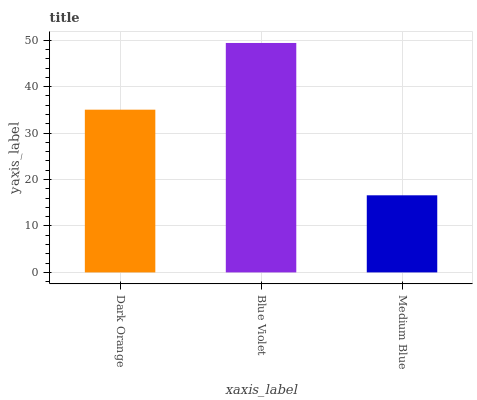Is Blue Violet the minimum?
Answer yes or no. No. Is Medium Blue the maximum?
Answer yes or no. No. Is Blue Violet greater than Medium Blue?
Answer yes or no. Yes. Is Medium Blue less than Blue Violet?
Answer yes or no. Yes. Is Medium Blue greater than Blue Violet?
Answer yes or no. No. Is Blue Violet less than Medium Blue?
Answer yes or no. No. Is Dark Orange the high median?
Answer yes or no. Yes. Is Dark Orange the low median?
Answer yes or no. Yes. Is Blue Violet the high median?
Answer yes or no. No. Is Blue Violet the low median?
Answer yes or no. No. 